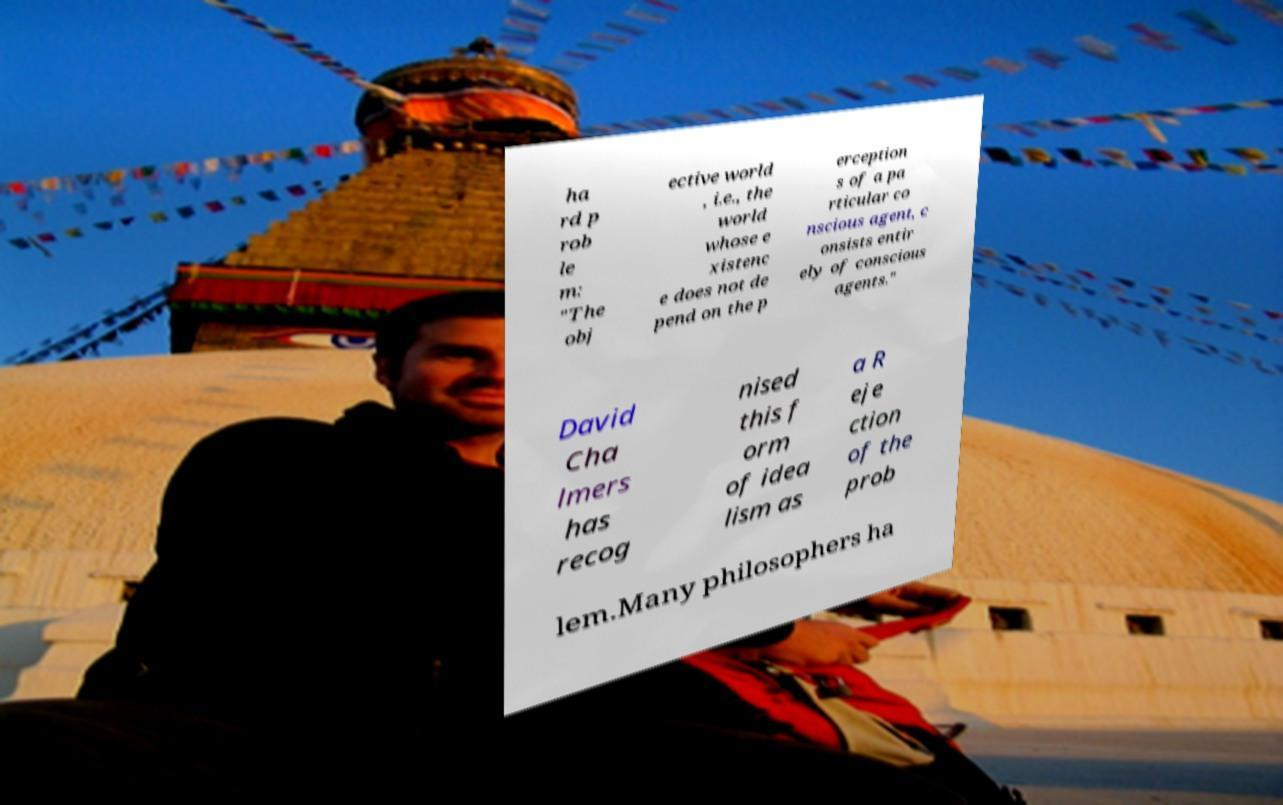Please identify and transcribe the text found in this image. ha rd p rob le m: "The obj ective world , i.e., the world whose e xistenc e does not de pend on the p erception s of a pa rticular co nscious agent, c onsists entir ely of conscious agents." David Cha lmers has recog nised this f orm of idea lism as a R eje ction of the prob lem.Many philosophers ha 